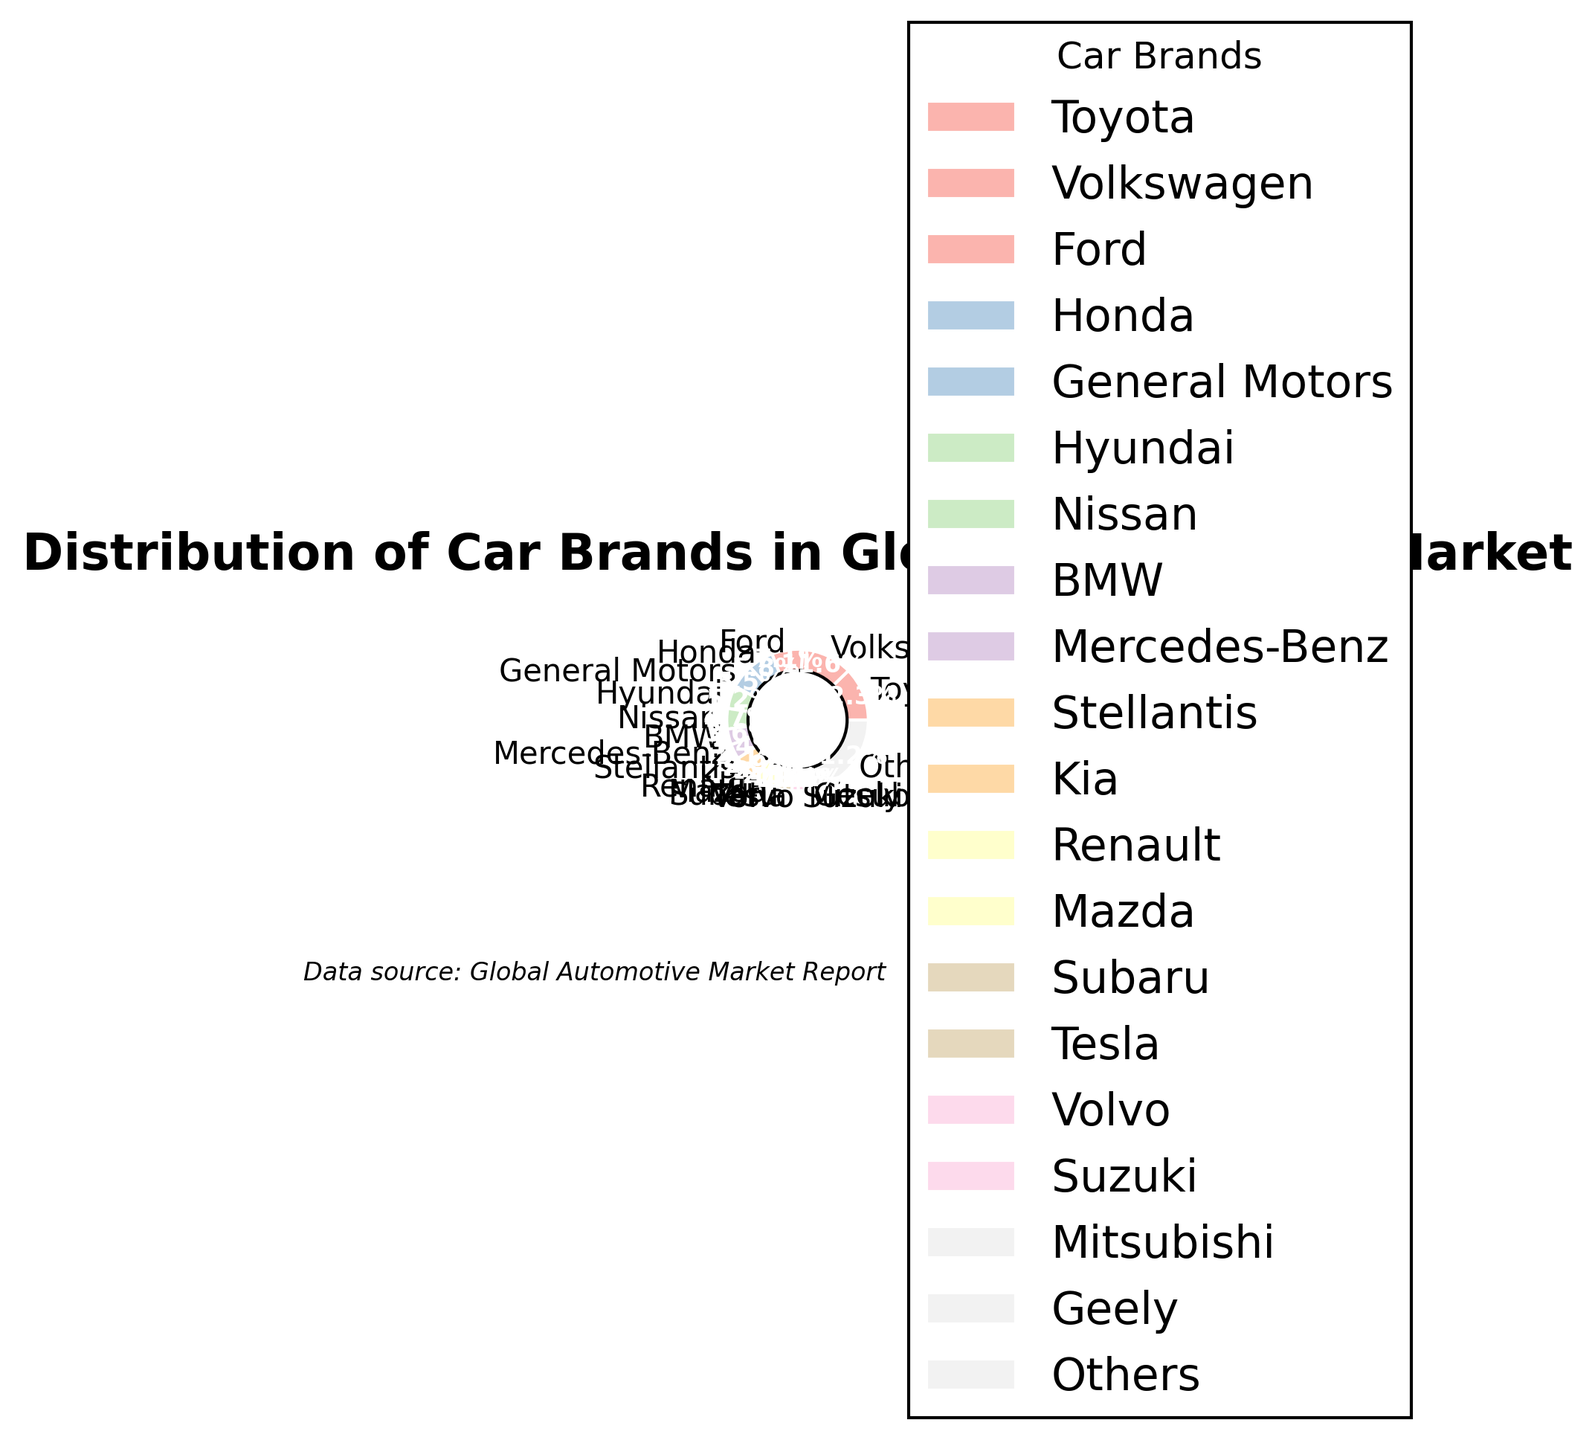What car brand has the largest market share? Toyota has the largest market share. This is evident from the pie chart where Toyota occupies the largest section.
Answer: Toyota Which car brands have less than 2% market share? By examining the pie chart, the car brands with less than 2% market share are Subaru, Tesla, Volvo, Suzuki, Mitsubishi, and Geely.
Answer: Subaru, Tesla, Volvo, Suzuki, Mitsubishi, Geely How much more market share does Toyota have than Honda? Toyota has 12.5% and Honda has 5.9%. The difference is calculated by subtracting Honda's share from Toyota's share: 12.5% - 5.9% = 6.6%.
Answer: 6.6% What is the combined market share of Ford and General Motors? Ford has 7.2% and General Motors has 5.6%. Add their market shares together to get the combined market share: 7.2% + 5.6% = 12.8%.
Answer: 12.8% Which car brand has a market share closest to 5%? By looking at the pie chart, Hyundai has a market share of 5.3%, which is closest to 5%.
Answer: Hyundai Which sector has the smallest slice on the pie chart, and what is its market share percentage? Geely has the smallest slice on the pie chart with a market share of 1.1%.
Answer: Geely, 1.1% What is the cumulative market share of the top three car brands? The top three brands are Toyota (12.5%), Volkswagen (11.8%), and Ford (7.2%). Summing these up: 12.5% + 11.8% + 7.2% = 31.5%.
Answer: 31.5% How does the market share of BMW compare to that of Mercedes-Benz? BMW has a market share of 3.7%, and Mercedes-Benz has a market share of 3.5%. BMW has a slightly larger market share than Mercedes-Benz.
Answer: BMW > Mercedes-Benz Identify three car brands whose combined market share is closest to 10%. Renault (2.8%), Mazda (2.3%), and Subaru (1.9%) combine to 7.0%, which is the closest sum around 10%.
Answer: Renault, Mazda, Subaru Which market share is larger: Subaru and Tesla combined or Renault alone? Subaru has 1.9% and Tesla has 1.7%. Combined, they make 3.6%. Renault alone has 2.8%. Therefore, Subaru and Tesla combined have a larger market share.
Answer: Subaru and Tesla 